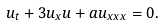<formula> <loc_0><loc_0><loc_500><loc_500>u _ { t } + 3 u _ { x } u + a u _ { x x x } = 0 .</formula> 